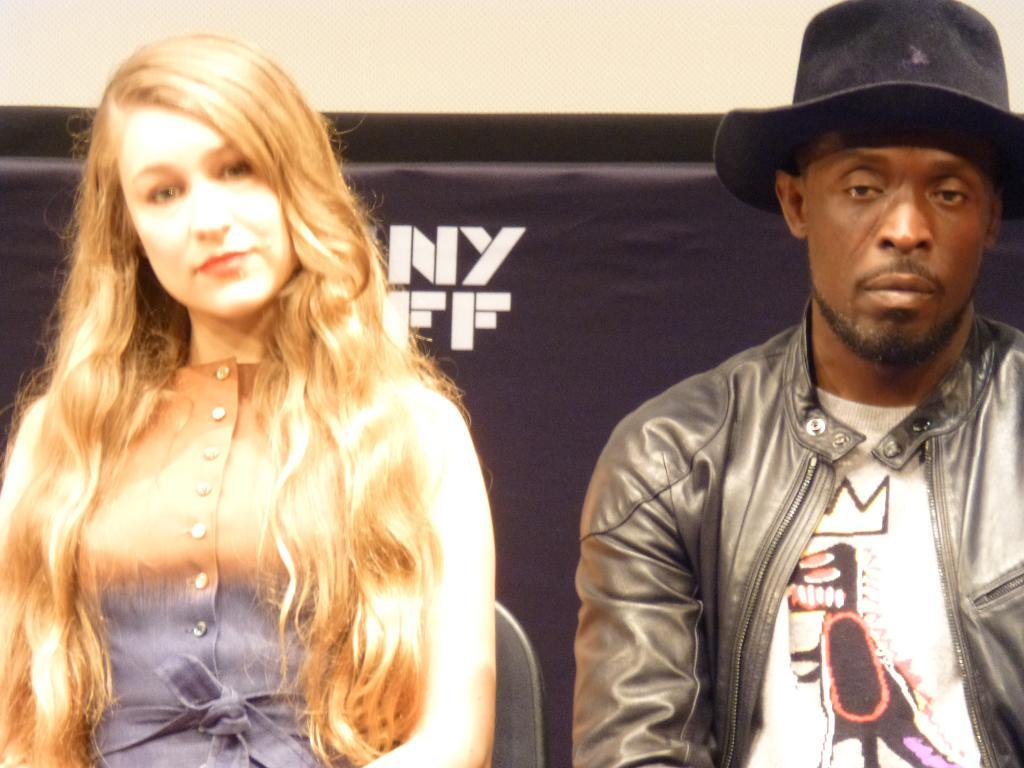How many people are present in the image? There are two persons in the image. Can you describe any objects or features in the background of the image? Yes, there is a banner or board in the background of the image. What type of record is being played by the person on the left in the image? There is no record or person playing a record present in the image. 